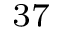<formula> <loc_0><loc_0><loc_500><loc_500>^ { 3 7 }</formula> 